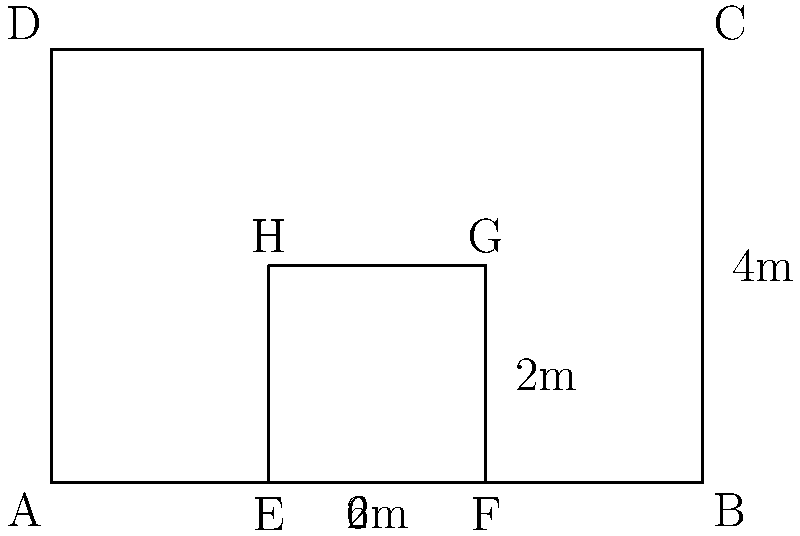As a project manager looking to optimize your team's workspace, you're redesigning the office layout. The current rectangular office space measures 6m by 4m. You want to create a centralized collaborative area in the middle, represented by the inner rectangle. If the collaborative area should occupy 1/3 of the total office space, what should be the dimensions of this inner rectangle? Let's approach this step-by-step:

1) First, calculate the total area of the office:
   Area = length × width
   Area = 6m × 4m = 24m²

2) The collaborative area should occupy 1/3 of the total space:
   Collaborative area = 1/3 × 24m² = 8m²

3) Let the width of the inner rectangle be $x$ and its length be $y$.
   We know that $x × y = 8$

4) We also know that the inner rectangle is centered, so it will have equal margins on all sides.
   If the width is $x$, then 6 - $x$ = twice the side margin
   If the length is $y$, then 4 - $y$ = twice the top/bottom margin

5) For the rectangle to be centered and proportional:
   $\frac{6-x}{2} = \frac{4-y}{2}$
   $6-x = 4-y$
   $y = x+2$

6) Substituting this into our area equation:
   $x(x+2) = 8$
   $x² + 2x - 8 = 0$

7) Solving this quadratic equation:
   $x = 2$ (we discard the negative solution)

8) If $x = 2$, then $y = 4$

Therefore, the dimensions of the inner rectangle should be 2m × 4m.
Answer: 2m × 4m 